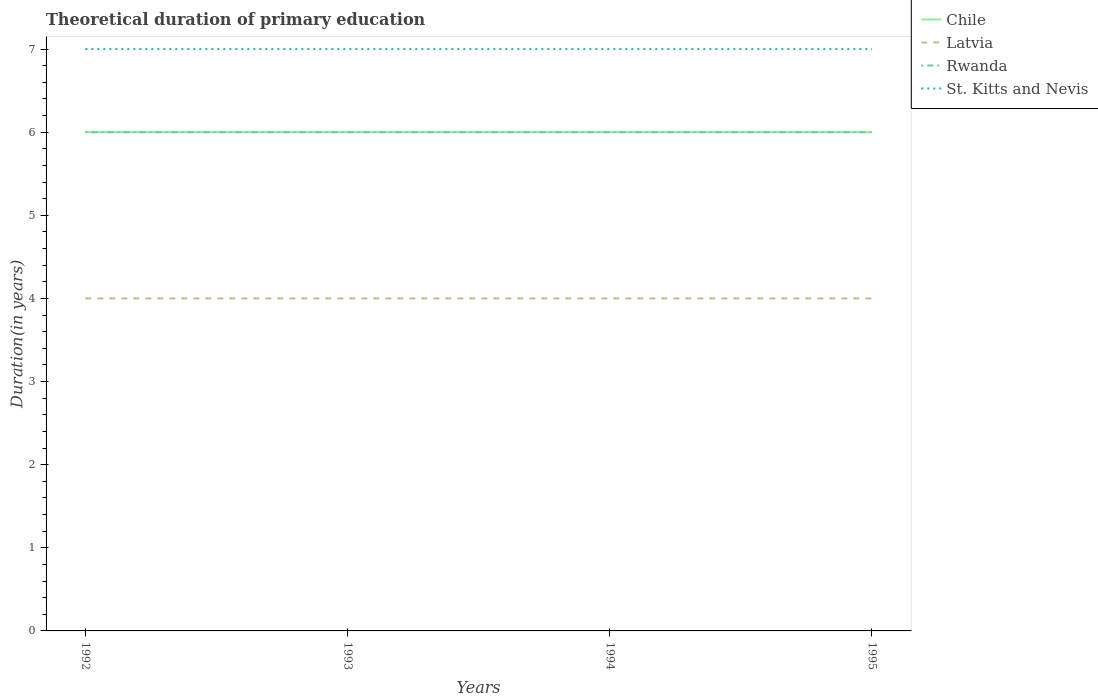How many different coloured lines are there?
Your answer should be compact. 4. Across all years, what is the maximum total theoretical duration of primary education in Latvia?
Ensure brevity in your answer.  4. In which year was the total theoretical duration of primary education in Latvia maximum?
Ensure brevity in your answer.  1992. What is the difference between the highest and the second highest total theoretical duration of primary education in Rwanda?
Provide a short and direct response. 0. How many lines are there?
Offer a very short reply. 4. How many years are there in the graph?
Give a very brief answer. 4. Does the graph contain any zero values?
Offer a terse response. No. What is the title of the graph?
Give a very brief answer. Theoretical duration of primary education. Does "Least developed countries" appear as one of the legend labels in the graph?
Ensure brevity in your answer.  No. What is the label or title of the X-axis?
Offer a very short reply. Years. What is the label or title of the Y-axis?
Make the answer very short. Duration(in years). What is the Duration(in years) of Chile in 1992?
Your response must be concise. 6. What is the Duration(in years) in Rwanda in 1992?
Offer a very short reply. 6. What is the Duration(in years) of Chile in 1993?
Provide a short and direct response. 6. What is the Duration(in years) of St. Kitts and Nevis in 1993?
Ensure brevity in your answer.  7. What is the Duration(in years) of Latvia in 1994?
Provide a short and direct response. 4. What is the Duration(in years) in Rwanda in 1994?
Provide a succinct answer. 6. What is the Duration(in years) of St. Kitts and Nevis in 1994?
Give a very brief answer. 7. What is the Duration(in years) of Latvia in 1995?
Provide a short and direct response. 4. What is the Duration(in years) of Rwanda in 1995?
Provide a succinct answer. 6. What is the Duration(in years) in St. Kitts and Nevis in 1995?
Offer a very short reply. 7. Across all years, what is the maximum Duration(in years) of Latvia?
Give a very brief answer. 4. Across all years, what is the maximum Duration(in years) in Rwanda?
Your response must be concise. 6. Across all years, what is the maximum Duration(in years) of St. Kitts and Nevis?
Provide a short and direct response. 7. Across all years, what is the minimum Duration(in years) in Latvia?
Offer a terse response. 4. Across all years, what is the minimum Duration(in years) in Rwanda?
Offer a terse response. 6. What is the total Duration(in years) in St. Kitts and Nevis in the graph?
Your response must be concise. 28. What is the difference between the Duration(in years) of Rwanda in 1992 and that in 1993?
Ensure brevity in your answer.  0. What is the difference between the Duration(in years) of Chile in 1992 and that in 1994?
Keep it short and to the point. 0. What is the difference between the Duration(in years) of St. Kitts and Nevis in 1992 and that in 1994?
Offer a terse response. 0. What is the difference between the Duration(in years) of Chile in 1992 and that in 1995?
Ensure brevity in your answer.  0. What is the difference between the Duration(in years) in St. Kitts and Nevis in 1992 and that in 1995?
Your answer should be very brief. 0. What is the difference between the Duration(in years) in Rwanda in 1993 and that in 1994?
Offer a terse response. 0. What is the difference between the Duration(in years) of Rwanda in 1993 and that in 1995?
Offer a very short reply. 0. What is the difference between the Duration(in years) in St. Kitts and Nevis in 1993 and that in 1995?
Your response must be concise. 0. What is the difference between the Duration(in years) in Latvia in 1994 and that in 1995?
Your answer should be compact. 0. What is the difference between the Duration(in years) of Chile in 1992 and the Duration(in years) of Latvia in 1993?
Offer a terse response. 2. What is the difference between the Duration(in years) in Chile in 1992 and the Duration(in years) in Rwanda in 1993?
Offer a very short reply. 0. What is the difference between the Duration(in years) of Latvia in 1992 and the Duration(in years) of Rwanda in 1993?
Your answer should be compact. -2. What is the difference between the Duration(in years) in Rwanda in 1992 and the Duration(in years) in St. Kitts and Nevis in 1993?
Offer a terse response. -1. What is the difference between the Duration(in years) of Chile in 1992 and the Duration(in years) of St. Kitts and Nevis in 1994?
Provide a succinct answer. -1. What is the difference between the Duration(in years) of Latvia in 1992 and the Duration(in years) of Rwanda in 1994?
Your response must be concise. -2. What is the difference between the Duration(in years) in Rwanda in 1992 and the Duration(in years) in St. Kitts and Nevis in 1994?
Ensure brevity in your answer.  -1. What is the difference between the Duration(in years) in Latvia in 1992 and the Duration(in years) in St. Kitts and Nevis in 1995?
Provide a succinct answer. -3. What is the difference between the Duration(in years) in Latvia in 1993 and the Duration(in years) in St. Kitts and Nevis in 1994?
Give a very brief answer. -3. What is the difference between the Duration(in years) in Rwanda in 1993 and the Duration(in years) in St. Kitts and Nevis in 1994?
Give a very brief answer. -1. What is the difference between the Duration(in years) in Chile in 1993 and the Duration(in years) in Latvia in 1995?
Provide a succinct answer. 2. What is the difference between the Duration(in years) of Chile in 1993 and the Duration(in years) of Rwanda in 1995?
Offer a terse response. 0. What is the difference between the Duration(in years) of Chile in 1993 and the Duration(in years) of St. Kitts and Nevis in 1995?
Your answer should be very brief. -1. What is the difference between the Duration(in years) of Latvia in 1993 and the Duration(in years) of Rwanda in 1995?
Give a very brief answer. -2. What is the difference between the Duration(in years) in Latvia in 1993 and the Duration(in years) in St. Kitts and Nevis in 1995?
Offer a terse response. -3. What is the difference between the Duration(in years) of Rwanda in 1993 and the Duration(in years) of St. Kitts and Nevis in 1995?
Keep it short and to the point. -1. What is the difference between the Duration(in years) in Chile in 1994 and the Duration(in years) in Rwanda in 1995?
Keep it short and to the point. 0. What is the difference between the Duration(in years) of Latvia in 1994 and the Duration(in years) of Rwanda in 1995?
Keep it short and to the point. -2. What is the difference between the Duration(in years) of Latvia in 1994 and the Duration(in years) of St. Kitts and Nevis in 1995?
Ensure brevity in your answer.  -3. What is the difference between the Duration(in years) of Rwanda in 1994 and the Duration(in years) of St. Kitts and Nevis in 1995?
Your response must be concise. -1. What is the average Duration(in years) of Chile per year?
Provide a short and direct response. 6. What is the average Duration(in years) in Latvia per year?
Provide a short and direct response. 4. What is the average Duration(in years) of Rwanda per year?
Offer a very short reply. 6. What is the average Duration(in years) in St. Kitts and Nevis per year?
Keep it short and to the point. 7. In the year 1992, what is the difference between the Duration(in years) in Chile and Duration(in years) in Latvia?
Your answer should be very brief. 2. In the year 1992, what is the difference between the Duration(in years) of Chile and Duration(in years) of Rwanda?
Offer a very short reply. 0. In the year 1992, what is the difference between the Duration(in years) in Latvia and Duration(in years) in Rwanda?
Your answer should be very brief. -2. In the year 1992, what is the difference between the Duration(in years) in Rwanda and Duration(in years) in St. Kitts and Nevis?
Your response must be concise. -1. In the year 1993, what is the difference between the Duration(in years) in Chile and Duration(in years) in Latvia?
Offer a very short reply. 2. In the year 1993, what is the difference between the Duration(in years) of Chile and Duration(in years) of Rwanda?
Your answer should be very brief. 0. In the year 1993, what is the difference between the Duration(in years) of Chile and Duration(in years) of St. Kitts and Nevis?
Provide a succinct answer. -1. In the year 1993, what is the difference between the Duration(in years) of Rwanda and Duration(in years) of St. Kitts and Nevis?
Offer a very short reply. -1. In the year 1994, what is the difference between the Duration(in years) in Chile and Duration(in years) in Latvia?
Your response must be concise. 2. In the year 1995, what is the difference between the Duration(in years) of Chile and Duration(in years) of Rwanda?
Provide a short and direct response. 0. In the year 1995, what is the difference between the Duration(in years) in Chile and Duration(in years) in St. Kitts and Nevis?
Your answer should be very brief. -1. In the year 1995, what is the difference between the Duration(in years) in Latvia and Duration(in years) in St. Kitts and Nevis?
Ensure brevity in your answer.  -3. What is the ratio of the Duration(in years) of Latvia in 1992 to that in 1993?
Offer a terse response. 1. What is the ratio of the Duration(in years) of Chile in 1992 to that in 1994?
Make the answer very short. 1. What is the ratio of the Duration(in years) in Latvia in 1992 to that in 1994?
Keep it short and to the point. 1. What is the ratio of the Duration(in years) of St. Kitts and Nevis in 1992 to that in 1994?
Make the answer very short. 1. What is the ratio of the Duration(in years) of Chile in 1992 to that in 1995?
Keep it short and to the point. 1. What is the ratio of the Duration(in years) in Chile in 1993 to that in 1995?
Provide a succinct answer. 1. What is the ratio of the Duration(in years) in Rwanda in 1993 to that in 1995?
Ensure brevity in your answer.  1. What is the ratio of the Duration(in years) of St. Kitts and Nevis in 1994 to that in 1995?
Your response must be concise. 1. What is the difference between the highest and the second highest Duration(in years) of Chile?
Offer a very short reply. 0. What is the difference between the highest and the second highest Duration(in years) in Rwanda?
Offer a terse response. 0. What is the difference between the highest and the lowest Duration(in years) in Chile?
Provide a short and direct response. 0. What is the difference between the highest and the lowest Duration(in years) of Rwanda?
Provide a succinct answer. 0. What is the difference between the highest and the lowest Duration(in years) in St. Kitts and Nevis?
Your answer should be very brief. 0. 